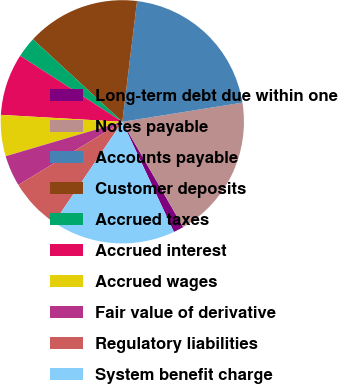Convert chart to OTSL. <chart><loc_0><loc_0><loc_500><loc_500><pie_chart><fcel>Long-term debt due within one<fcel>Notes payable<fcel>Accounts payable<fcel>Customer deposits<fcel>Accrued taxes<fcel>Accrued interest<fcel>Accrued wages<fcel>Fair value of derivative<fcel>Regulatory liabilities<fcel>System benefit charge<nl><fcel>1.37%<fcel>19.18%<fcel>20.55%<fcel>15.07%<fcel>2.74%<fcel>8.22%<fcel>5.48%<fcel>4.11%<fcel>6.85%<fcel>16.44%<nl></chart> 